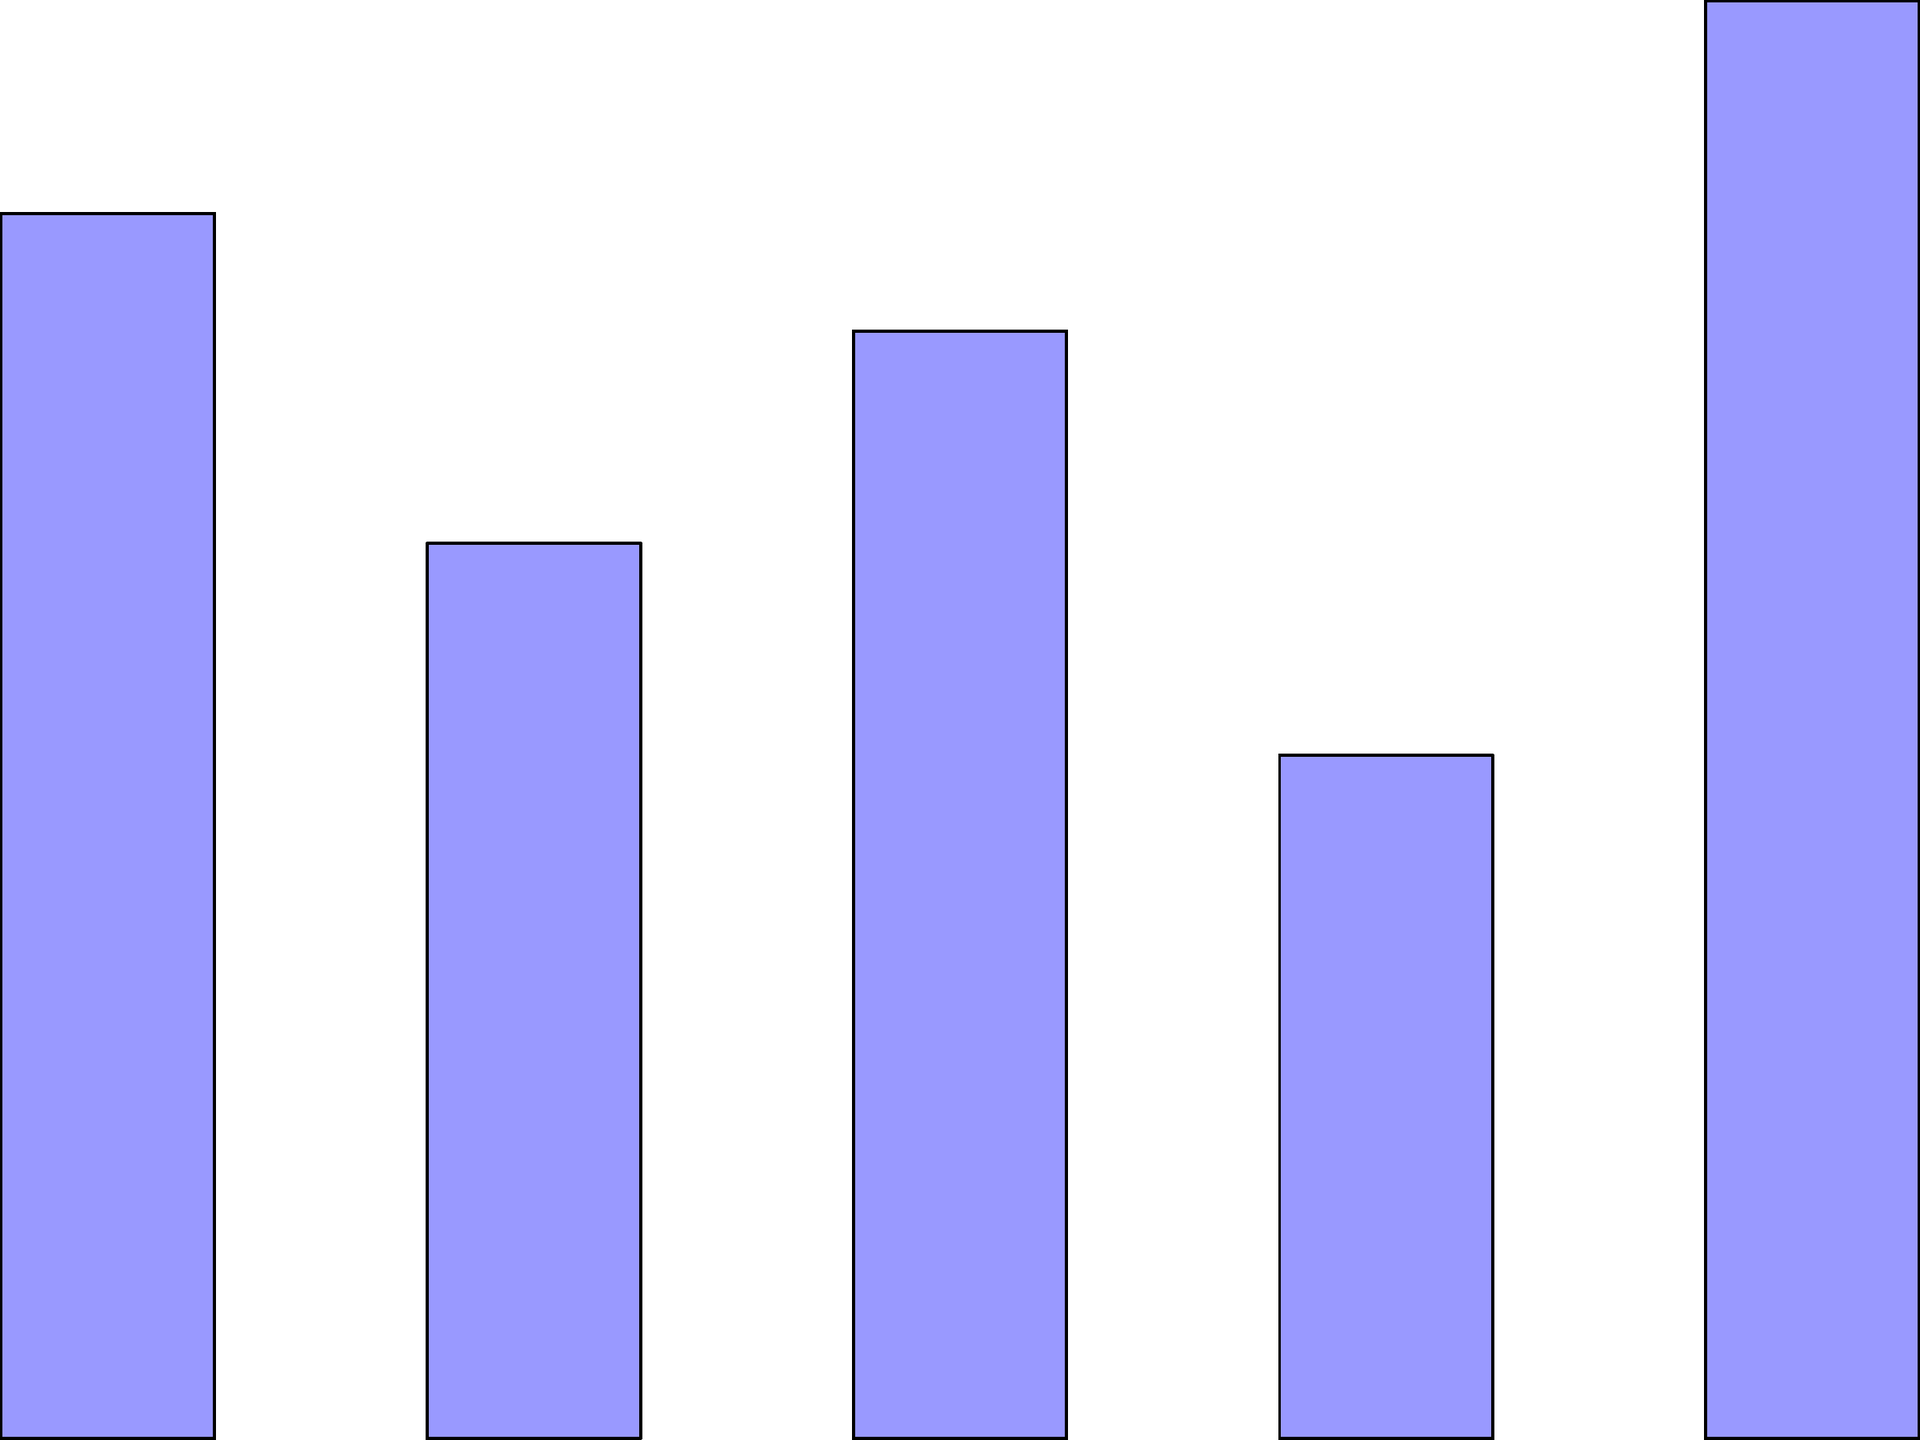Analyze the violent crime rates depicted in the bar graph. Which state shows the highest rate, and how does this information align with the "tough-on-crime" narrative often promoted in political discourse? Discuss potential factors contributing to the variations in crime rates across these states. To answer this question, let's analyze the graph step-by-step:

1. Identify the highest crime rate:
   - IL (Illinois) has the highest bar, reaching approximately 6.1 violent crimes per 1,000 residents.

2. Compare rates across states:
   - IL: ~6.1
   - NY: ~5.2
   - TX: ~4.7
   - CA: ~3.8
   - FL: ~2.9

3. Align with "tough-on-crime" narrative:
   - The significant variations in crime rates could be used to argue for stricter law enforcement and sentencing in high-crime states.
   - IL's high rate might be used to criticize current policies and push for tougher measures.

4. Potential factors contributing to variations:
   a) Socioeconomic conditions: Poverty rates, unemployment, income inequality
   b) Urban vs. rural population distribution
   c) Law enforcement strategies and resources
   d) Gun control laws and firearm availability
   e) Drug policies and addiction rates
   f) Gang activity and organized crime presence
   g) Educational opportunities and social programs
   h) Demographic factors: age distribution, population density

5. Policy implications:
   - Advocates for tough-on-crime policies might use this data to push for:
     - Increased police presence in high-crime areas
     - Harsher sentencing for violent offenders
     - Enhanced surveillance and crime prevention technologies
     - Stricter parole and probation regulations

6. Critical analysis:
   - It's important to note that crime rates alone don't tell the whole story. Factors such as reporting practices, definition of violent crime, and socioeconomic context must be considered for a comprehensive understanding.
Answer: Illinois has the highest violent crime rate. This data could support tough-on-crime policies, but multiple factors (socioeconomic, urban density, law enforcement strategies) contribute to rate variations across states. 